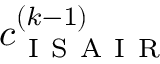Convert formula to latex. <formula><loc_0><loc_0><loc_500><loc_500>c _ { I S A I R } ^ { ( k - 1 ) }</formula> 